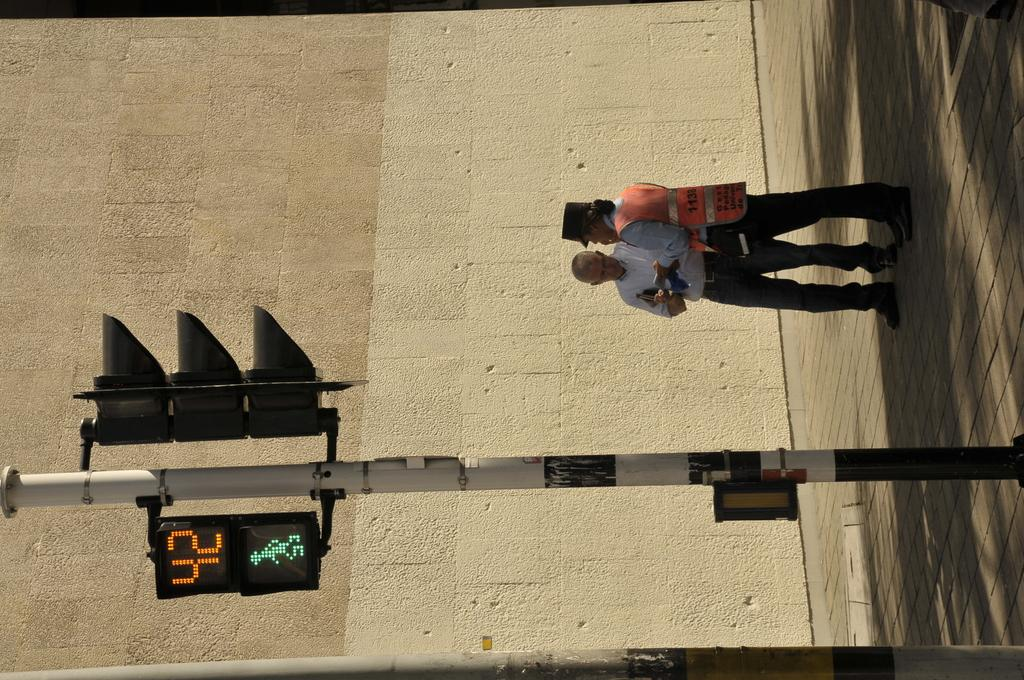<image>
Provide a brief description of the given image. Pedestrians have 42 seconds to safely cross the street. 